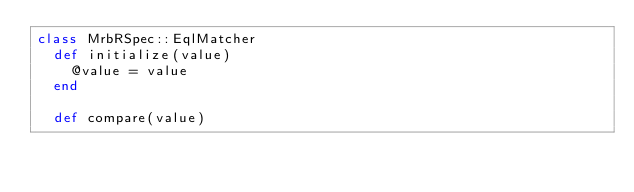<code> <loc_0><loc_0><loc_500><loc_500><_Ruby_>class MrbRSpec::EqlMatcher
  def initialize(value)
    @value = value
  end

  def compare(value)</code> 